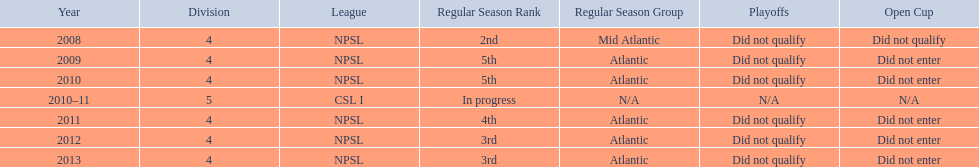What are all of the leagues? NPSL, NPSL, NPSL, CSL I, NPSL, NPSL, NPSL. Could you help me parse every detail presented in this table? {'header': ['Year', 'Division', 'League', 'Regular Season Rank', 'Regular Season Group', 'Playoffs', 'Open Cup'], 'rows': [['2008', '4', 'NPSL', '2nd', 'Mid Atlantic', 'Did not qualify', 'Did not qualify'], ['2009', '4', 'NPSL', '5th', 'Atlantic', 'Did not qualify', 'Did not enter'], ['2010', '4', 'NPSL', '5th', 'Atlantic', 'Did not qualify', 'Did not enter'], ['2010–11', '5', 'CSL I', 'In progress', 'N/A', 'N/A', 'N/A'], ['2011', '4', 'NPSL', '4th', 'Atlantic', 'Did not qualify', 'Did not enter'], ['2012', '4', 'NPSL', '3rd', 'Atlantic', 'Did not qualify', 'Did not enter'], ['2013', '4', 'NPSL', '3rd', 'Atlantic', 'Did not qualify', 'Did not enter']]} Which league was played in the least? CSL I. 